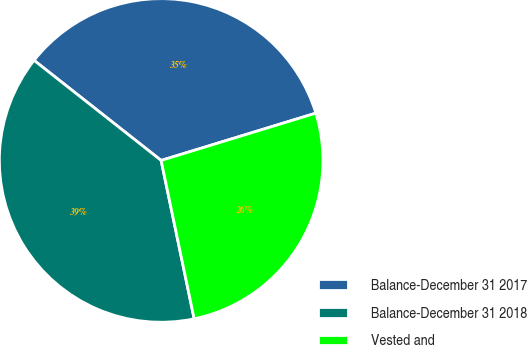Convert chart. <chart><loc_0><loc_0><loc_500><loc_500><pie_chart><fcel>Balance-December 31 2017<fcel>Balance-December 31 2018<fcel>Vested and<nl><fcel>34.66%<fcel>38.89%<fcel>26.45%<nl></chart> 